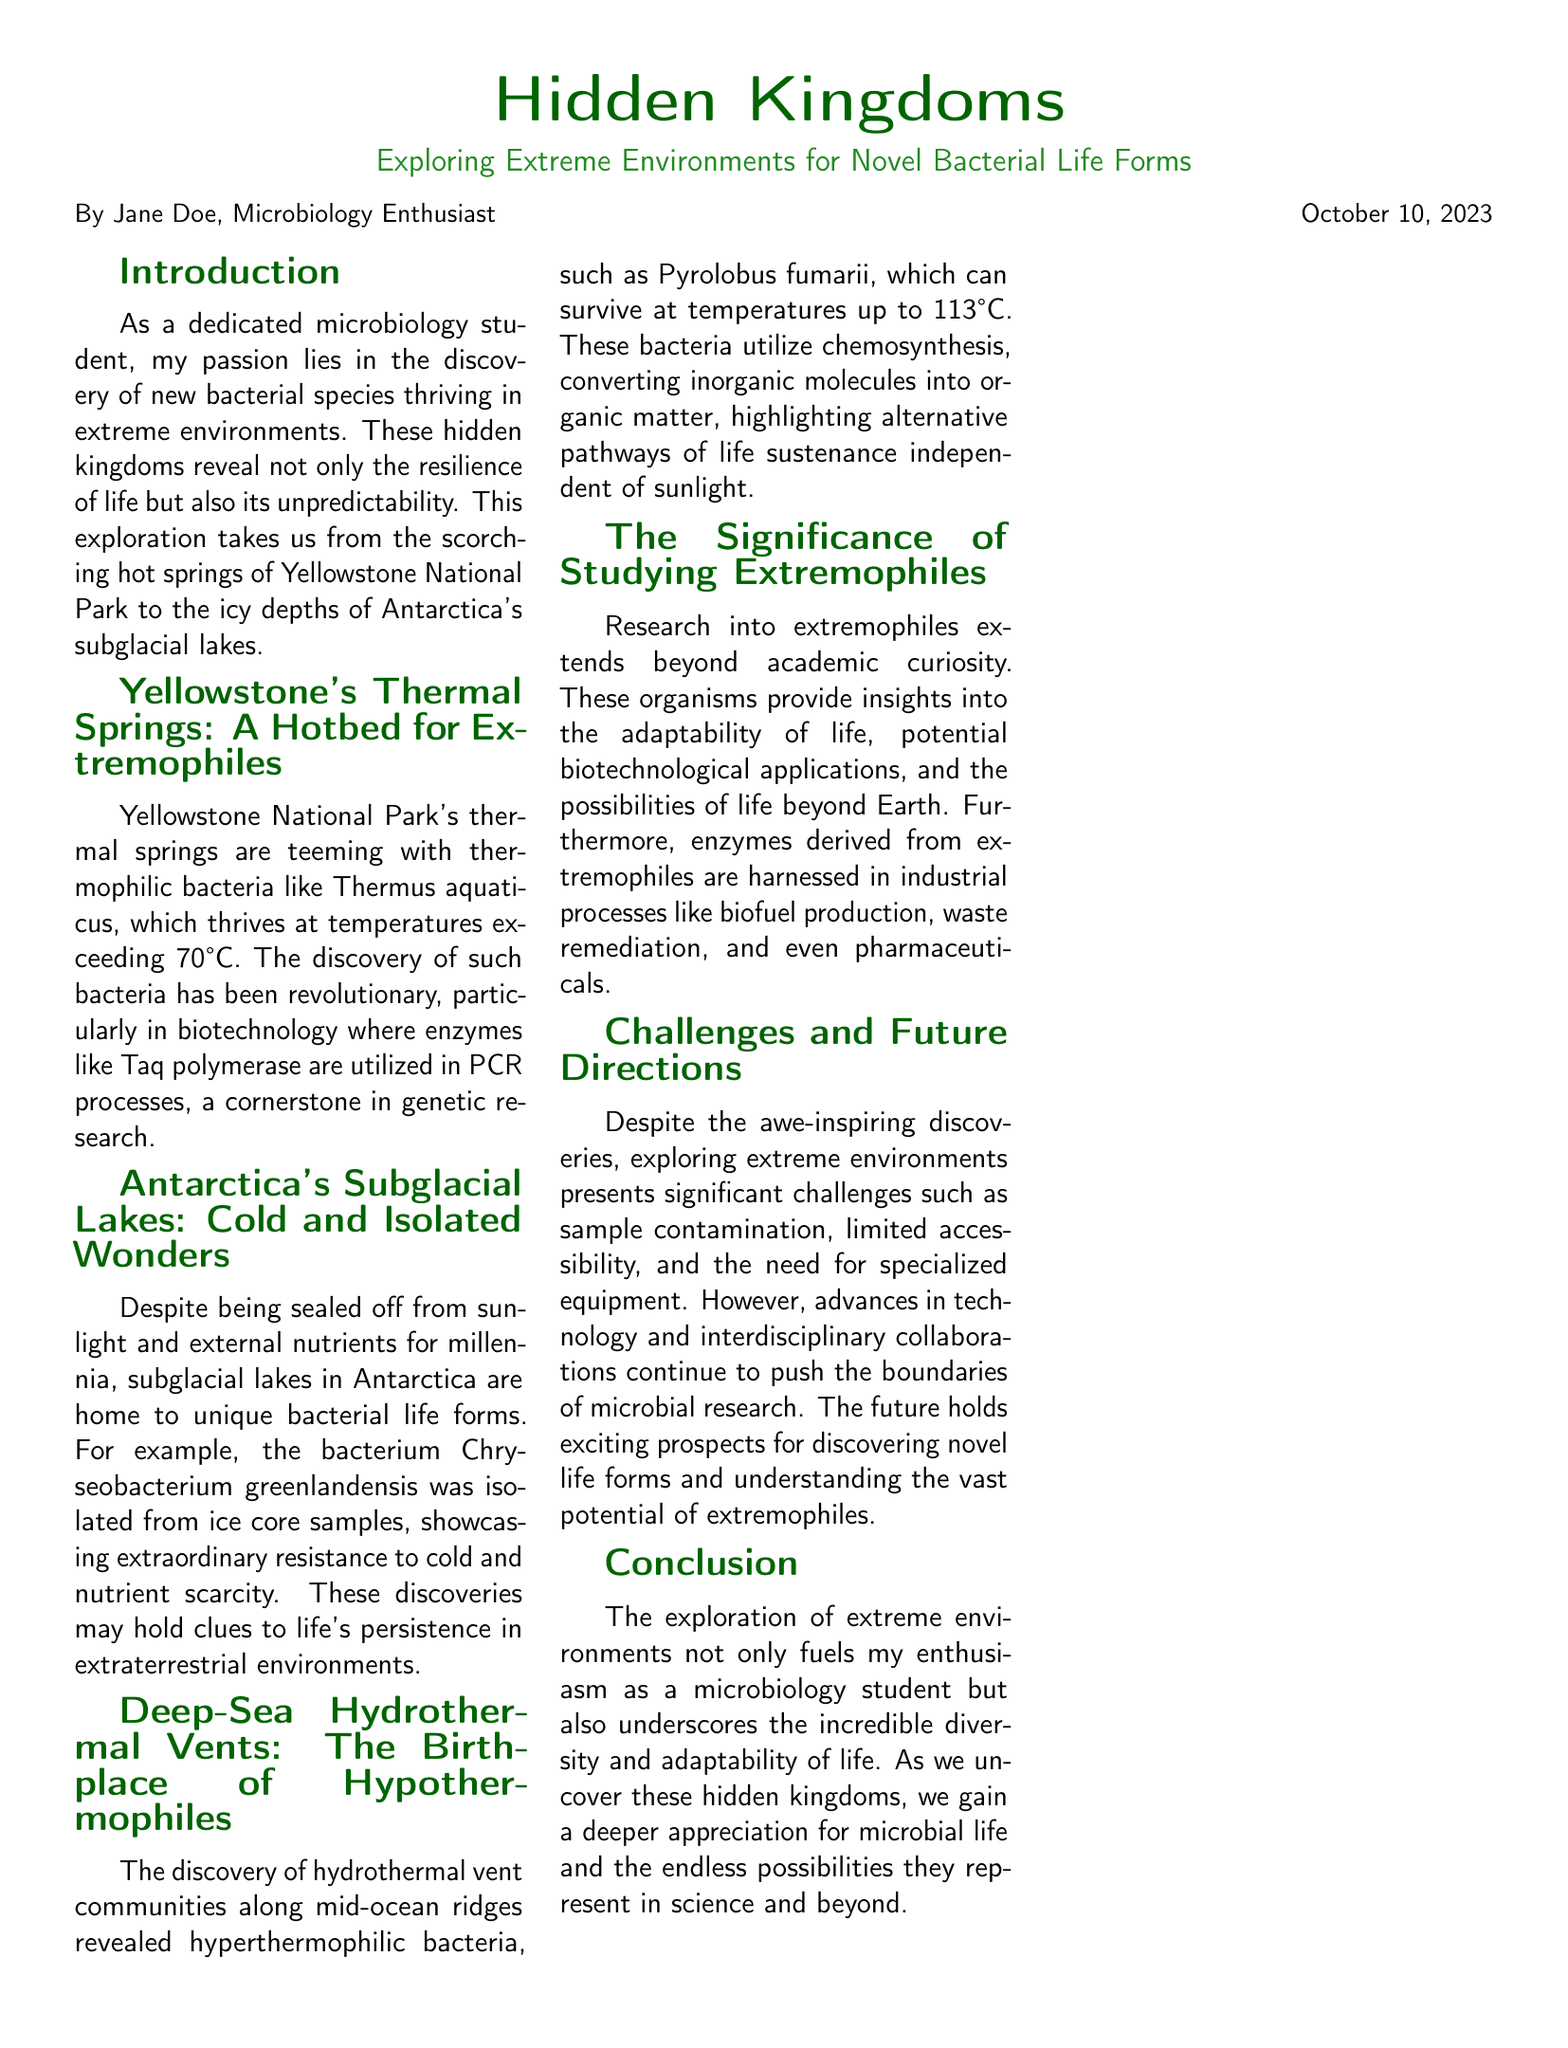What is the title of the document? The title is clearly stated at the top of the document.
Answer: Hidden Kingdoms Who is the author of the article? The author's name is mentioned in the document's header.
Answer: Jane Doe What bacterium thrives at temperatures exceeding 70°C in Yellowstone? This information can be found in the section about Yellowstone's thermal springs.
Answer: Thermus aquaticus Which bacterium was isolated from ice core samples in Antarctica? This detail is provided in the section discussing Antarctica's subglacial lakes.
Answer: Chryseobacterium greenlandensis What temperature can Pyrolobus fumarii survive at? The survival temperature of this bacterium is mentioned in the section about deep-sea hydrothermal vents.
Answer: 113°C What type of environments are explored in this document? The types of environments explored are specified throughout the text.
Answer: Extreme environments What is one application of enzymes derived from extremophiles? The document discusses potential applications of extremophiles in the significance section.
Answer: Biofuel production What is a major challenge mentioned in exploring extreme environments? This information can be found in the section on challenges and future directions.
Answer: Sample contamination What does the exploration of extreme environments underscore? This key takeaway is provided in the conclusion of the article.
Answer: Incredible diversity and adaptability of life 